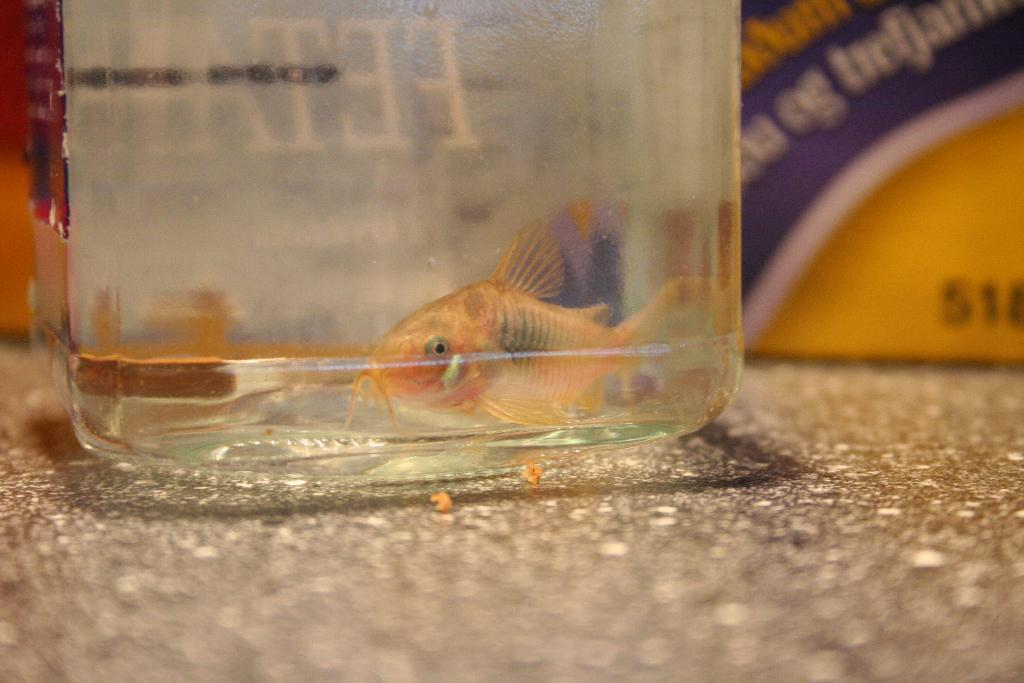What is inside the container in the image? There is a gold-colored fish in the container. Can you describe the container in the image? The container is the main subject in the image, and it holds the gold-colored fish. What is visible on the surface in the image? The surface is visible in the image, but it is not clear what it is or what is on it. What can be seen in the background of the image? There is text or writing in the background of the image. What type of crime is being committed by the horses in the image? There are no horses present in the image, and therefore no crime can be committed by them. 